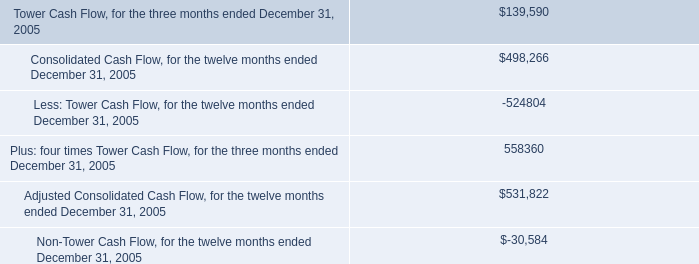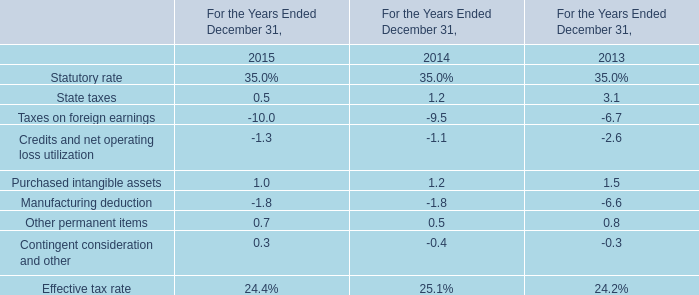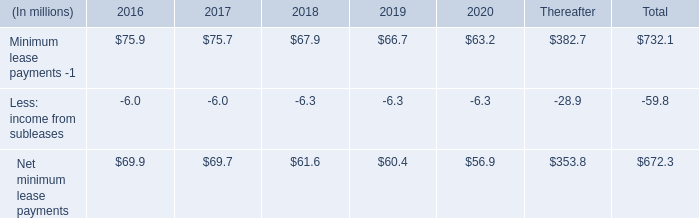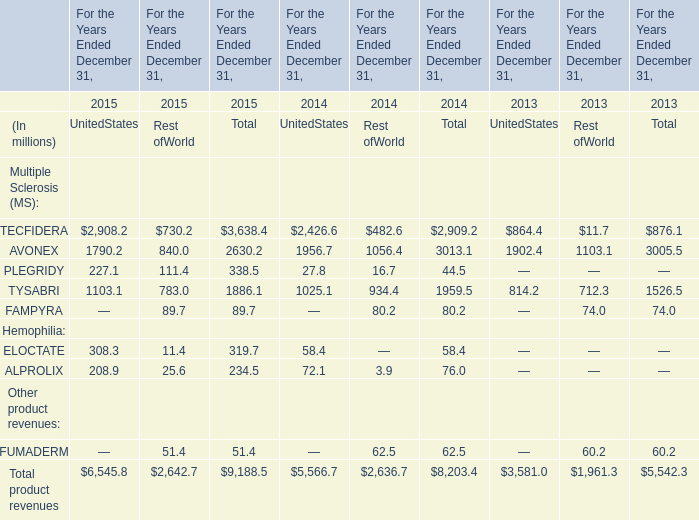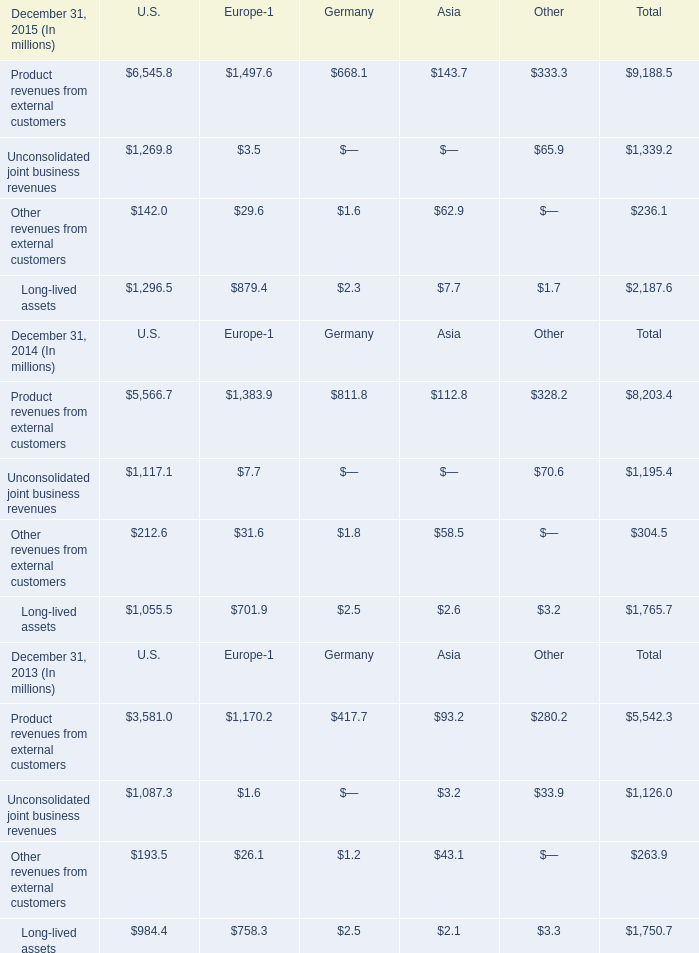What is the growing rate of Unconsolidated joint business revenues in the year with the most December 31, 2015 ? 
Computations: ((1339.2 - 1195.4) / 1339.2)
Answer: 0.10738. 